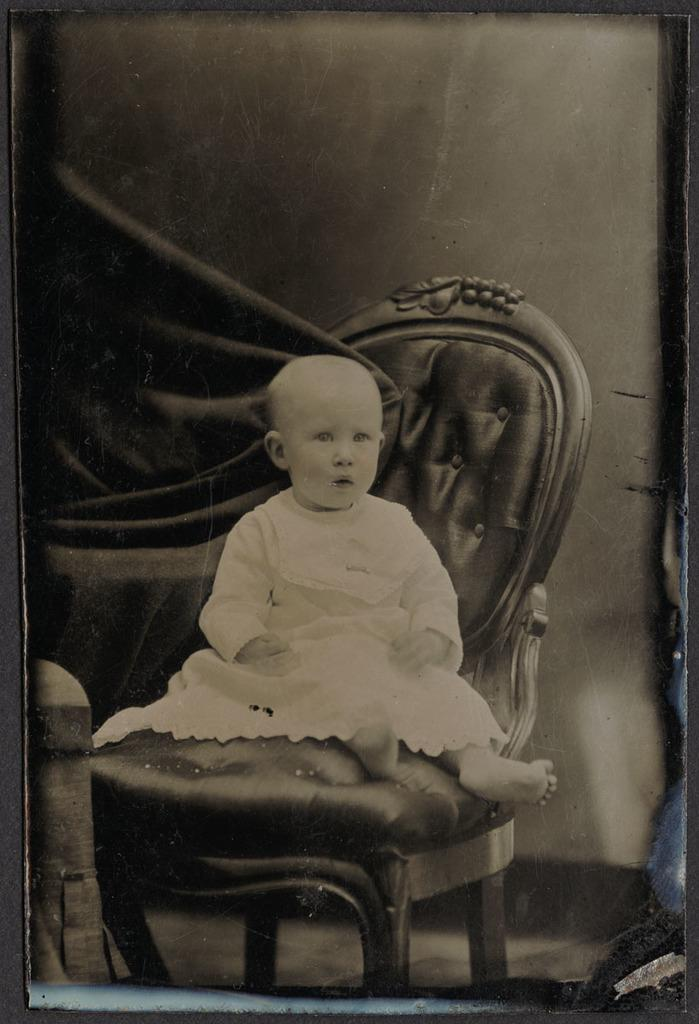What is depicted on the poster in the image? There is a poster of a person sitting on a chair in the image. What can be seen below the poster in the image? The ground is visible in the image. What object is located on the bottom left side of the image? There is an object on the bottom left side of the image, but its description is not provided in the facts. What type of oatmeal is being served at the cemetery in the image? There is no cemetery or oatmeal present in the image. The image only features a poster of a person sitting on a chair and the ground below it. 